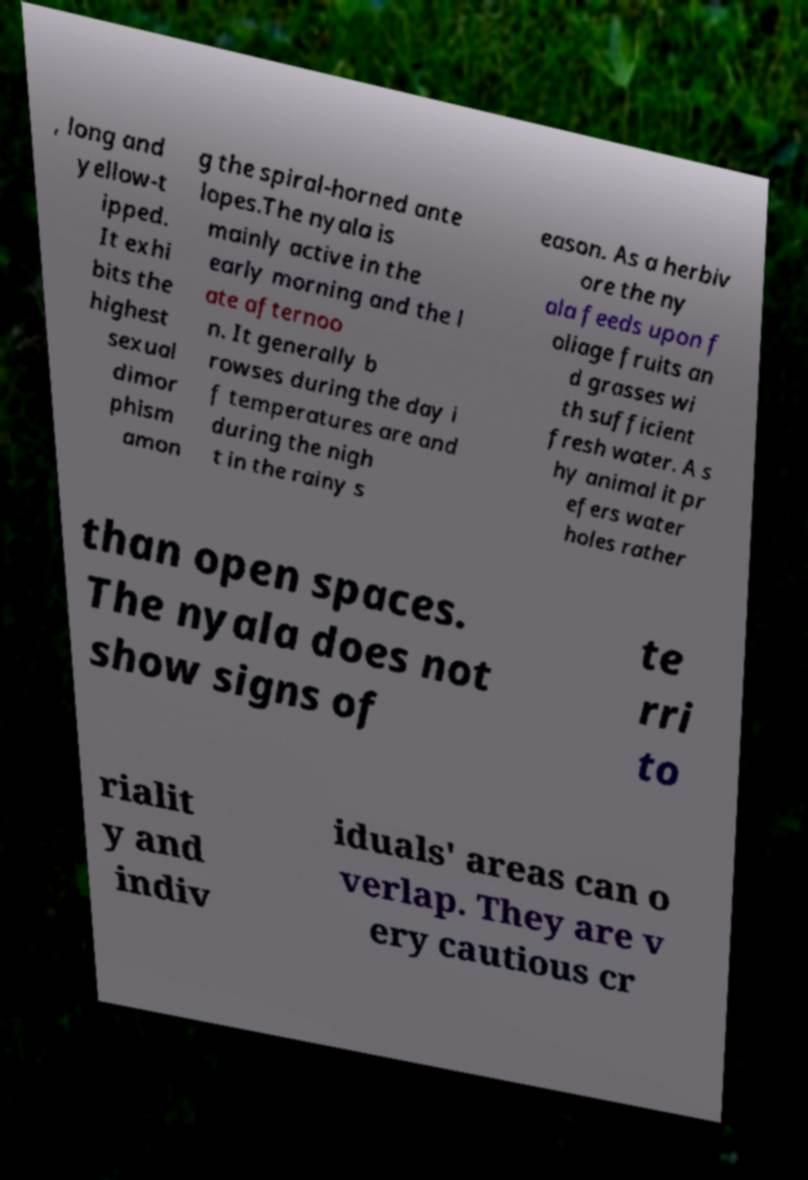Please identify and transcribe the text found in this image. , long and yellow-t ipped. It exhi bits the highest sexual dimor phism amon g the spiral-horned ante lopes.The nyala is mainly active in the early morning and the l ate afternoo n. It generally b rowses during the day i f temperatures are and during the nigh t in the rainy s eason. As a herbiv ore the ny ala feeds upon f oliage fruits an d grasses wi th sufficient fresh water. A s hy animal it pr efers water holes rather than open spaces. The nyala does not show signs of te rri to rialit y and indiv iduals' areas can o verlap. They are v ery cautious cr 